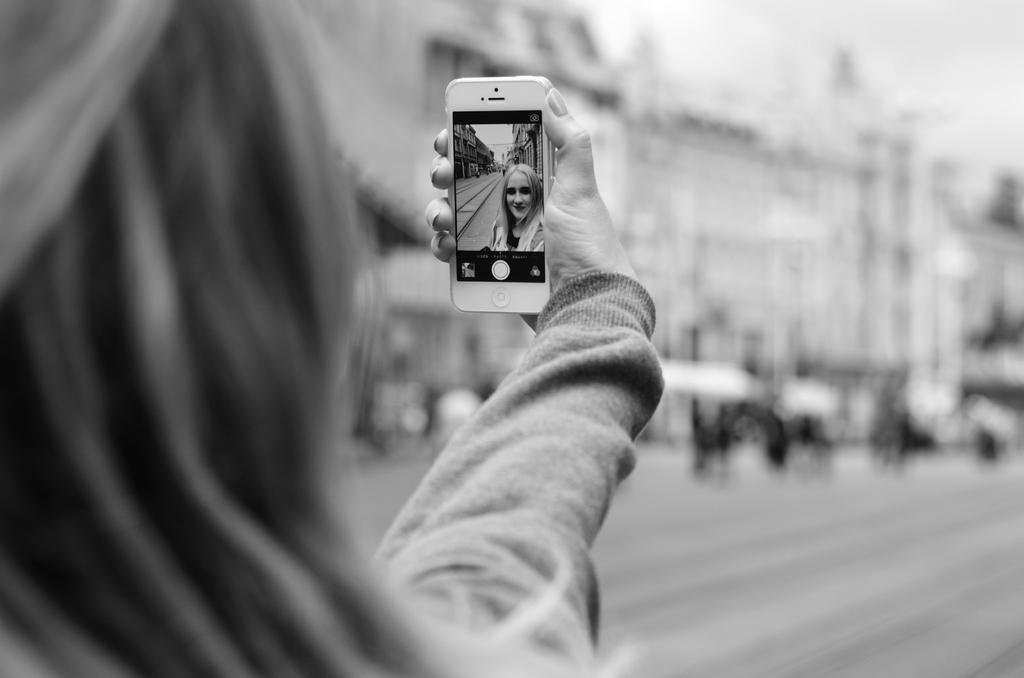What is the main subject of the image? There is a person in the image. What is the person doing in the image? The person is taking a selfie, as she is holding a device (likely a smartphone) in her hand. What can be seen in the background of the image? There is a building in the image. Are there any other people present in the image? Yes, there are many other people in the image. What type of silk fabric is being used by the passenger in the image? There is no passenger or silk fabric present in the image. What class of education does the person in the image belong to? There is no information about the person's education in the image. 